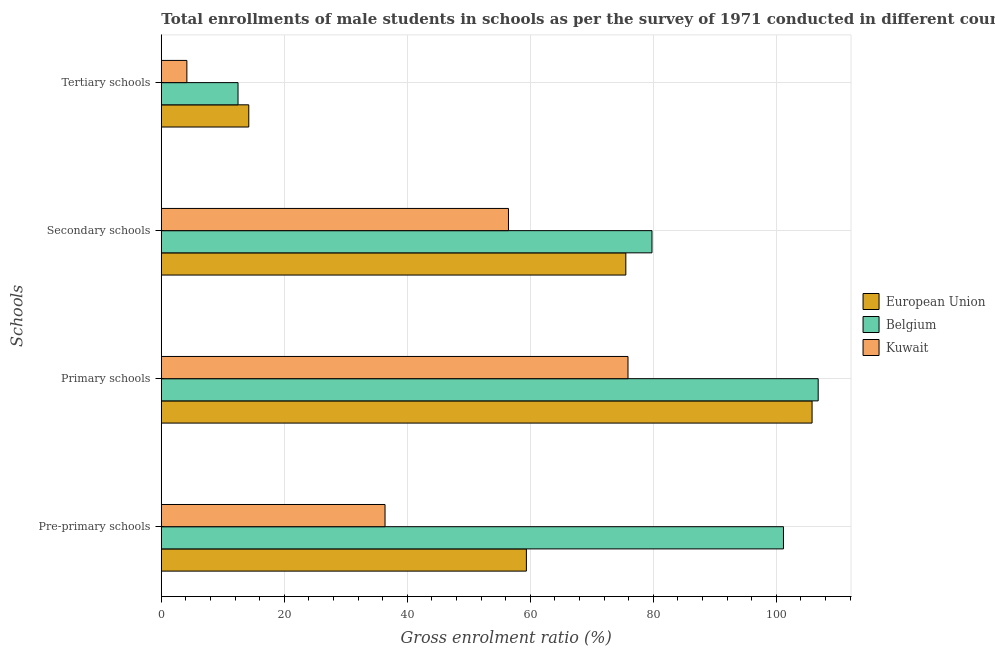How many different coloured bars are there?
Your answer should be compact. 3. How many groups of bars are there?
Your response must be concise. 4. Are the number of bars per tick equal to the number of legend labels?
Provide a succinct answer. Yes. How many bars are there on the 1st tick from the top?
Your response must be concise. 3. How many bars are there on the 2nd tick from the bottom?
Ensure brevity in your answer.  3. What is the label of the 4th group of bars from the top?
Your answer should be very brief. Pre-primary schools. What is the gross enrolment ratio(male) in tertiary schools in European Union?
Your answer should be very brief. 14.22. Across all countries, what is the maximum gross enrolment ratio(male) in pre-primary schools?
Ensure brevity in your answer.  101.17. Across all countries, what is the minimum gross enrolment ratio(male) in secondary schools?
Offer a terse response. 56.45. In which country was the gross enrolment ratio(male) in primary schools minimum?
Give a very brief answer. Kuwait. What is the total gross enrolment ratio(male) in tertiary schools in the graph?
Your response must be concise. 30.85. What is the difference between the gross enrolment ratio(male) in primary schools in Belgium and that in Kuwait?
Offer a very short reply. 30.93. What is the difference between the gross enrolment ratio(male) in pre-primary schools in European Union and the gross enrolment ratio(male) in tertiary schools in Kuwait?
Your answer should be very brief. 55.21. What is the average gross enrolment ratio(male) in tertiary schools per country?
Make the answer very short. 10.28. What is the difference between the gross enrolment ratio(male) in primary schools and gross enrolment ratio(male) in tertiary schools in Belgium?
Make the answer very short. 94.34. In how many countries, is the gross enrolment ratio(male) in tertiary schools greater than 72 %?
Ensure brevity in your answer.  0. What is the ratio of the gross enrolment ratio(male) in secondary schools in European Union to that in Belgium?
Your answer should be compact. 0.95. Is the gross enrolment ratio(male) in pre-primary schools in Kuwait less than that in Belgium?
Provide a succinct answer. Yes. What is the difference between the highest and the second highest gross enrolment ratio(male) in pre-primary schools?
Your answer should be very brief. 41.81. What is the difference between the highest and the lowest gross enrolment ratio(male) in primary schools?
Your response must be concise. 30.93. In how many countries, is the gross enrolment ratio(male) in secondary schools greater than the average gross enrolment ratio(male) in secondary schools taken over all countries?
Provide a short and direct response. 2. Is the sum of the gross enrolment ratio(male) in secondary schools in Belgium and European Union greater than the maximum gross enrolment ratio(male) in primary schools across all countries?
Give a very brief answer. Yes. What does the 2nd bar from the top in Pre-primary schools represents?
Offer a terse response. Belgium. How many bars are there?
Ensure brevity in your answer.  12. How many countries are there in the graph?
Make the answer very short. 3. Are the values on the major ticks of X-axis written in scientific E-notation?
Your answer should be very brief. No. Does the graph contain any zero values?
Your response must be concise. No. Where does the legend appear in the graph?
Offer a terse response. Center right. What is the title of the graph?
Your answer should be very brief. Total enrollments of male students in schools as per the survey of 1971 conducted in different countries. Does "Sint Maarten (Dutch part)" appear as one of the legend labels in the graph?
Your answer should be compact. No. What is the label or title of the X-axis?
Offer a very short reply. Gross enrolment ratio (%). What is the label or title of the Y-axis?
Offer a very short reply. Schools. What is the Gross enrolment ratio (%) of European Union in Pre-primary schools?
Your answer should be very brief. 59.36. What is the Gross enrolment ratio (%) of Belgium in Pre-primary schools?
Provide a short and direct response. 101.17. What is the Gross enrolment ratio (%) in Kuwait in Pre-primary schools?
Ensure brevity in your answer.  36.38. What is the Gross enrolment ratio (%) of European Union in Primary schools?
Provide a succinct answer. 105.82. What is the Gross enrolment ratio (%) in Belgium in Primary schools?
Your answer should be very brief. 106.82. What is the Gross enrolment ratio (%) in Kuwait in Primary schools?
Ensure brevity in your answer.  75.89. What is the Gross enrolment ratio (%) of European Union in Secondary schools?
Give a very brief answer. 75.54. What is the Gross enrolment ratio (%) of Belgium in Secondary schools?
Give a very brief answer. 79.79. What is the Gross enrolment ratio (%) of Kuwait in Secondary schools?
Offer a very short reply. 56.45. What is the Gross enrolment ratio (%) of European Union in Tertiary schools?
Offer a terse response. 14.22. What is the Gross enrolment ratio (%) in Belgium in Tertiary schools?
Make the answer very short. 12.47. What is the Gross enrolment ratio (%) in Kuwait in Tertiary schools?
Your answer should be compact. 4.16. Across all Schools, what is the maximum Gross enrolment ratio (%) of European Union?
Offer a terse response. 105.82. Across all Schools, what is the maximum Gross enrolment ratio (%) in Belgium?
Provide a short and direct response. 106.82. Across all Schools, what is the maximum Gross enrolment ratio (%) of Kuwait?
Keep it short and to the point. 75.89. Across all Schools, what is the minimum Gross enrolment ratio (%) in European Union?
Offer a terse response. 14.22. Across all Schools, what is the minimum Gross enrolment ratio (%) of Belgium?
Give a very brief answer. 12.47. Across all Schools, what is the minimum Gross enrolment ratio (%) of Kuwait?
Your answer should be compact. 4.16. What is the total Gross enrolment ratio (%) in European Union in the graph?
Offer a terse response. 254.94. What is the total Gross enrolment ratio (%) in Belgium in the graph?
Your answer should be compact. 300.25. What is the total Gross enrolment ratio (%) of Kuwait in the graph?
Make the answer very short. 172.88. What is the difference between the Gross enrolment ratio (%) in European Union in Pre-primary schools and that in Primary schools?
Keep it short and to the point. -46.46. What is the difference between the Gross enrolment ratio (%) of Belgium in Pre-primary schools and that in Primary schools?
Offer a terse response. -5.65. What is the difference between the Gross enrolment ratio (%) of Kuwait in Pre-primary schools and that in Primary schools?
Your answer should be compact. -39.51. What is the difference between the Gross enrolment ratio (%) in European Union in Pre-primary schools and that in Secondary schools?
Your answer should be very brief. -16.17. What is the difference between the Gross enrolment ratio (%) in Belgium in Pre-primary schools and that in Secondary schools?
Offer a terse response. 21.38. What is the difference between the Gross enrolment ratio (%) in Kuwait in Pre-primary schools and that in Secondary schools?
Provide a succinct answer. -20.07. What is the difference between the Gross enrolment ratio (%) in European Union in Pre-primary schools and that in Tertiary schools?
Your response must be concise. 45.14. What is the difference between the Gross enrolment ratio (%) in Belgium in Pre-primary schools and that in Tertiary schools?
Provide a short and direct response. 88.7. What is the difference between the Gross enrolment ratio (%) in Kuwait in Pre-primary schools and that in Tertiary schools?
Give a very brief answer. 32.22. What is the difference between the Gross enrolment ratio (%) in European Union in Primary schools and that in Secondary schools?
Give a very brief answer. 30.29. What is the difference between the Gross enrolment ratio (%) of Belgium in Primary schools and that in Secondary schools?
Your answer should be very brief. 27.03. What is the difference between the Gross enrolment ratio (%) of Kuwait in Primary schools and that in Secondary schools?
Provide a succinct answer. 19.44. What is the difference between the Gross enrolment ratio (%) in European Union in Primary schools and that in Tertiary schools?
Provide a succinct answer. 91.6. What is the difference between the Gross enrolment ratio (%) of Belgium in Primary schools and that in Tertiary schools?
Give a very brief answer. 94.34. What is the difference between the Gross enrolment ratio (%) in Kuwait in Primary schools and that in Tertiary schools?
Your answer should be very brief. 71.73. What is the difference between the Gross enrolment ratio (%) of European Union in Secondary schools and that in Tertiary schools?
Your answer should be very brief. 61.31. What is the difference between the Gross enrolment ratio (%) in Belgium in Secondary schools and that in Tertiary schools?
Your response must be concise. 67.31. What is the difference between the Gross enrolment ratio (%) of Kuwait in Secondary schools and that in Tertiary schools?
Your answer should be compact. 52.3. What is the difference between the Gross enrolment ratio (%) in European Union in Pre-primary schools and the Gross enrolment ratio (%) in Belgium in Primary schools?
Your answer should be very brief. -47.45. What is the difference between the Gross enrolment ratio (%) in European Union in Pre-primary schools and the Gross enrolment ratio (%) in Kuwait in Primary schools?
Offer a very short reply. -16.52. What is the difference between the Gross enrolment ratio (%) of Belgium in Pre-primary schools and the Gross enrolment ratio (%) of Kuwait in Primary schools?
Make the answer very short. 25.28. What is the difference between the Gross enrolment ratio (%) of European Union in Pre-primary schools and the Gross enrolment ratio (%) of Belgium in Secondary schools?
Offer a very short reply. -20.42. What is the difference between the Gross enrolment ratio (%) in European Union in Pre-primary schools and the Gross enrolment ratio (%) in Kuwait in Secondary schools?
Make the answer very short. 2.91. What is the difference between the Gross enrolment ratio (%) in Belgium in Pre-primary schools and the Gross enrolment ratio (%) in Kuwait in Secondary schools?
Your response must be concise. 44.72. What is the difference between the Gross enrolment ratio (%) of European Union in Pre-primary schools and the Gross enrolment ratio (%) of Belgium in Tertiary schools?
Offer a terse response. 46.89. What is the difference between the Gross enrolment ratio (%) of European Union in Pre-primary schools and the Gross enrolment ratio (%) of Kuwait in Tertiary schools?
Provide a short and direct response. 55.21. What is the difference between the Gross enrolment ratio (%) of Belgium in Pre-primary schools and the Gross enrolment ratio (%) of Kuwait in Tertiary schools?
Make the answer very short. 97.01. What is the difference between the Gross enrolment ratio (%) in European Union in Primary schools and the Gross enrolment ratio (%) in Belgium in Secondary schools?
Ensure brevity in your answer.  26.03. What is the difference between the Gross enrolment ratio (%) of European Union in Primary schools and the Gross enrolment ratio (%) of Kuwait in Secondary schools?
Your answer should be very brief. 49.37. What is the difference between the Gross enrolment ratio (%) of Belgium in Primary schools and the Gross enrolment ratio (%) of Kuwait in Secondary schools?
Keep it short and to the point. 50.36. What is the difference between the Gross enrolment ratio (%) of European Union in Primary schools and the Gross enrolment ratio (%) of Belgium in Tertiary schools?
Offer a terse response. 93.35. What is the difference between the Gross enrolment ratio (%) of European Union in Primary schools and the Gross enrolment ratio (%) of Kuwait in Tertiary schools?
Give a very brief answer. 101.66. What is the difference between the Gross enrolment ratio (%) in Belgium in Primary schools and the Gross enrolment ratio (%) in Kuwait in Tertiary schools?
Keep it short and to the point. 102.66. What is the difference between the Gross enrolment ratio (%) of European Union in Secondary schools and the Gross enrolment ratio (%) of Belgium in Tertiary schools?
Offer a very short reply. 63.06. What is the difference between the Gross enrolment ratio (%) of European Union in Secondary schools and the Gross enrolment ratio (%) of Kuwait in Tertiary schools?
Offer a very short reply. 71.38. What is the difference between the Gross enrolment ratio (%) in Belgium in Secondary schools and the Gross enrolment ratio (%) in Kuwait in Tertiary schools?
Offer a very short reply. 75.63. What is the average Gross enrolment ratio (%) of European Union per Schools?
Keep it short and to the point. 63.74. What is the average Gross enrolment ratio (%) in Belgium per Schools?
Give a very brief answer. 75.06. What is the average Gross enrolment ratio (%) of Kuwait per Schools?
Keep it short and to the point. 43.22. What is the difference between the Gross enrolment ratio (%) in European Union and Gross enrolment ratio (%) in Belgium in Pre-primary schools?
Your answer should be very brief. -41.81. What is the difference between the Gross enrolment ratio (%) of European Union and Gross enrolment ratio (%) of Kuwait in Pre-primary schools?
Keep it short and to the point. 22.98. What is the difference between the Gross enrolment ratio (%) of Belgium and Gross enrolment ratio (%) of Kuwait in Pre-primary schools?
Make the answer very short. 64.79. What is the difference between the Gross enrolment ratio (%) in European Union and Gross enrolment ratio (%) in Belgium in Primary schools?
Keep it short and to the point. -1. What is the difference between the Gross enrolment ratio (%) of European Union and Gross enrolment ratio (%) of Kuwait in Primary schools?
Give a very brief answer. 29.93. What is the difference between the Gross enrolment ratio (%) in Belgium and Gross enrolment ratio (%) in Kuwait in Primary schools?
Provide a short and direct response. 30.93. What is the difference between the Gross enrolment ratio (%) in European Union and Gross enrolment ratio (%) in Belgium in Secondary schools?
Ensure brevity in your answer.  -4.25. What is the difference between the Gross enrolment ratio (%) of European Union and Gross enrolment ratio (%) of Kuwait in Secondary schools?
Your response must be concise. 19.08. What is the difference between the Gross enrolment ratio (%) in Belgium and Gross enrolment ratio (%) in Kuwait in Secondary schools?
Make the answer very short. 23.34. What is the difference between the Gross enrolment ratio (%) of European Union and Gross enrolment ratio (%) of Belgium in Tertiary schools?
Give a very brief answer. 1.75. What is the difference between the Gross enrolment ratio (%) in European Union and Gross enrolment ratio (%) in Kuwait in Tertiary schools?
Give a very brief answer. 10.07. What is the difference between the Gross enrolment ratio (%) in Belgium and Gross enrolment ratio (%) in Kuwait in Tertiary schools?
Give a very brief answer. 8.32. What is the ratio of the Gross enrolment ratio (%) in European Union in Pre-primary schools to that in Primary schools?
Provide a succinct answer. 0.56. What is the ratio of the Gross enrolment ratio (%) of Belgium in Pre-primary schools to that in Primary schools?
Make the answer very short. 0.95. What is the ratio of the Gross enrolment ratio (%) in Kuwait in Pre-primary schools to that in Primary schools?
Make the answer very short. 0.48. What is the ratio of the Gross enrolment ratio (%) of European Union in Pre-primary schools to that in Secondary schools?
Give a very brief answer. 0.79. What is the ratio of the Gross enrolment ratio (%) of Belgium in Pre-primary schools to that in Secondary schools?
Make the answer very short. 1.27. What is the ratio of the Gross enrolment ratio (%) of Kuwait in Pre-primary schools to that in Secondary schools?
Provide a short and direct response. 0.64. What is the ratio of the Gross enrolment ratio (%) of European Union in Pre-primary schools to that in Tertiary schools?
Keep it short and to the point. 4.17. What is the ratio of the Gross enrolment ratio (%) of Belgium in Pre-primary schools to that in Tertiary schools?
Make the answer very short. 8.11. What is the ratio of the Gross enrolment ratio (%) of Kuwait in Pre-primary schools to that in Tertiary schools?
Ensure brevity in your answer.  8.75. What is the ratio of the Gross enrolment ratio (%) in European Union in Primary schools to that in Secondary schools?
Your answer should be compact. 1.4. What is the ratio of the Gross enrolment ratio (%) in Belgium in Primary schools to that in Secondary schools?
Your answer should be very brief. 1.34. What is the ratio of the Gross enrolment ratio (%) in Kuwait in Primary schools to that in Secondary schools?
Your answer should be compact. 1.34. What is the ratio of the Gross enrolment ratio (%) in European Union in Primary schools to that in Tertiary schools?
Your response must be concise. 7.44. What is the ratio of the Gross enrolment ratio (%) in Belgium in Primary schools to that in Tertiary schools?
Provide a succinct answer. 8.56. What is the ratio of the Gross enrolment ratio (%) in Kuwait in Primary schools to that in Tertiary schools?
Ensure brevity in your answer.  18.26. What is the ratio of the Gross enrolment ratio (%) in European Union in Secondary schools to that in Tertiary schools?
Give a very brief answer. 5.31. What is the ratio of the Gross enrolment ratio (%) in Belgium in Secondary schools to that in Tertiary schools?
Give a very brief answer. 6.4. What is the ratio of the Gross enrolment ratio (%) of Kuwait in Secondary schools to that in Tertiary schools?
Give a very brief answer. 13.58. What is the difference between the highest and the second highest Gross enrolment ratio (%) of European Union?
Offer a terse response. 30.29. What is the difference between the highest and the second highest Gross enrolment ratio (%) in Belgium?
Your response must be concise. 5.65. What is the difference between the highest and the second highest Gross enrolment ratio (%) of Kuwait?
Offer a terse response. 19.44. What is the difference between the highest and the lowest Gross enrolment ratio (%) in European Union?
Provide a succinct answer. 91.6. What is the difference between the highest and the lowest Gross enrolment ratio (%) in Belgium?
Make the answer very short. 94.34. What is the difference between the highest and the lowest Gross enrolment ratio (%) in Kuwait?
Your answer should be very brief. 71.73. 